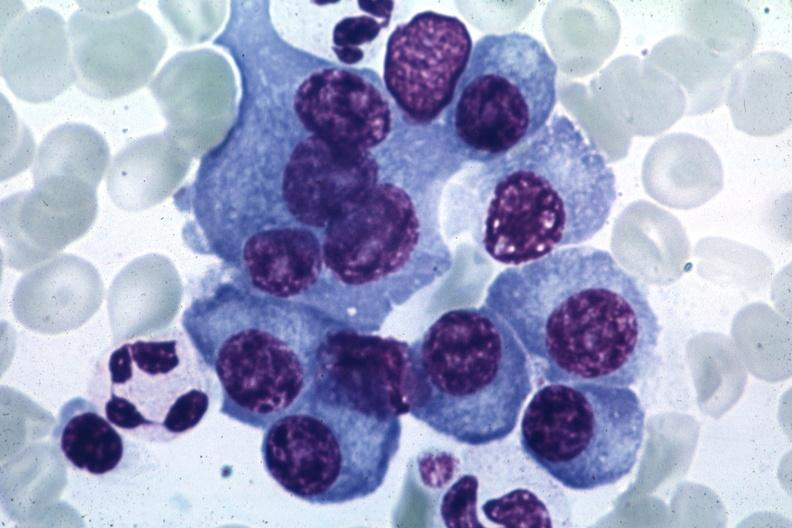s granulomata slide present?
Answer the question using a single word or phrase. No 